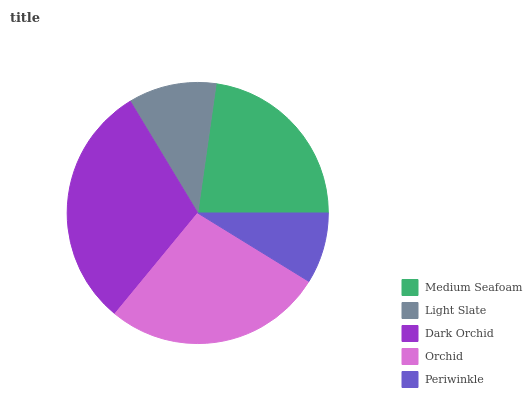Is Periwinkle the minimum?
Answer yes or no. Yes. Is Dark Orchid the maximum?
Answer yes or no. Yes. Is Light Slate the minimum?
Answer yes or no. No. Is Light Slate the maximum?
Answer yes or no. No. Is Medium Seafoam greater than Light Slate?
Answer yes or no. Yes. Is Light Slate less than Medium Seafoam?
Answer yes or no. Yes. Is Light Slate greater than Medium Seafoam?
Answer yes or no. No. Is Medium Seafoam less than Light Slate?
Answer yes or no. No. Is Medium Seafoam the high median?
Answer yes or no. Yes. Is Medium Seafoam the low median?
Answer yes or no. Yes. Is Dark Orchid the high median?
Answer yes or no. No. Is Dark Orchid the low median?
Answer yes or no. No. 